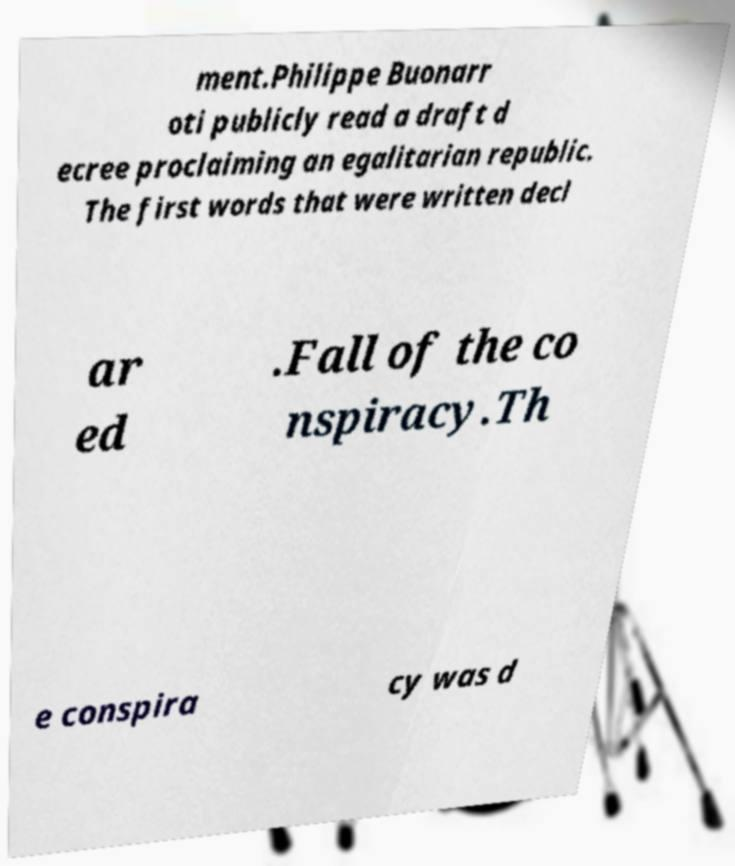There's text embedded in this image that I need extracted. Can you transcribe it verbatim? ment.Philippe Buonarr oti publicly read a draft d ecree proclaiming an egalitarian republic. The first words that were written decl ar ed .Fall of the co nspiracy.Th e conspira cy was d 